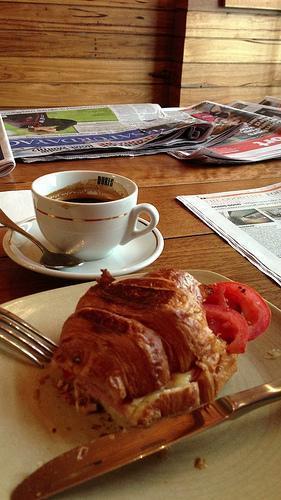How many cups are on the table?
Give a very brief answer. 1. How many papers are there?
Give a very brief answer. 3. How many forks are there?
Give a very brief answer. 1. How many forks are on the plate?
Give a very brief answer. 1. 